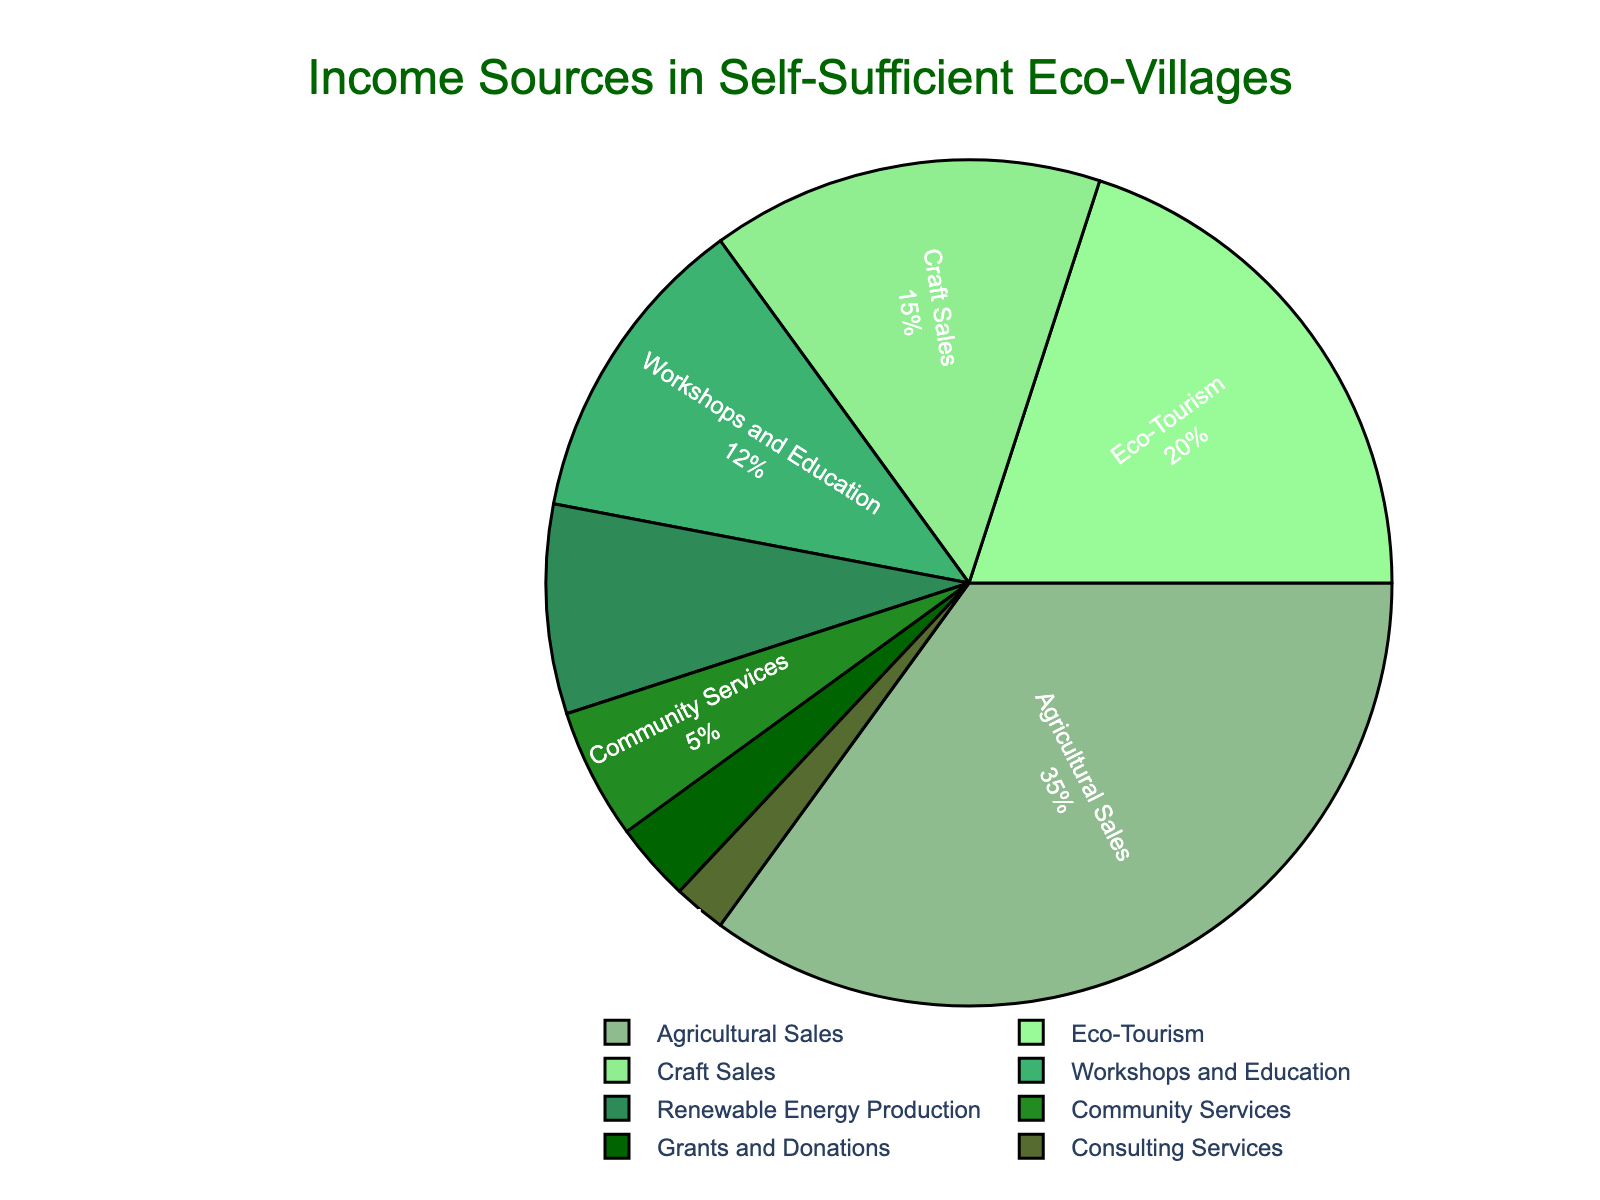What's the largest income source for the self-sufficient eco-villages? The largest portion of the pie chart represents Agricultural Sales, which is 35%.
Answer: Agricultural Sales How much more income does Agricultural Sales generate compared to Craft Sales? Agricultural Sales is 35%, and Craft Sales is 15%, so the difference is 35% - 15% = 20%.
Answer: 20% Which category contributes the least to the income? The smallest portion of the pie chart represents Consulting Services, which is 2%.
Answer: Consulting Services What percentage of the total income is generated by Eco-Tourism and Workshops and Education combined? The percentages for Eco-Tourism and Workshops and Education are 20% and 12% respectively. Summing them up, 20% + 12% = 32%.
Answer: 32% How does the income from Eco-Tourism compare to Renewable Energy Production? Eco-Tourism generates 20% of the income, while Renewable Energy Production generates 8%. Therefore, Eco-Tourism generates 20% - 8% = 12% more income.
Answer: 12% more What are the two income sources that contribute the most to the eco-village's income and what is their combined percentage? The two largest sources are Agricultural Sales (35%) and Eco-Tourism (20%). Combined, their contribution is 35% + 20% = 55%.
Answer: Agricultural Sales and Eco-Tourism, 55% What portion of the eco-village's income comes from education-related activities? Workshops and Education represent the portion related to education, which is 12%.
Answer: 12% How much more income does Community Services generate compared to Grants and Donations? Community Services contribute 5%, while Grants and Donations contribute 3%. Therefore, Community Services generate 5% - 3% = 2% more income.
Answer: 2% more What percentage of income comes from non-sales activities (excluding Agricultural Sales, Craft Sales, and Eco-Tourism)? Non-sales activities are Workshops and Education (12%), Renewable Energy Production (8%), Community Services (5%), Grants and Donations (3%), and Consulting Services (2%). Summing them up, 12% + 8% + 5% + 3% + 2% = 30%.
Answer: 30% What is the difference in the percentages between the top three income sources combined and the lowest three income sources combined? The top three sources are Agricultural Sales (35%), Eco-Tourism (20%), and Craft Sales (15%). Their combined percentage is 35% + 20% + 15% = 70%. The lowest three sources are Community Services (5%), Grants and Donations (3%), and Consulting Services (2%). Their combined percentage is 5% + 3% + 2% = 10%. The difference is 70% - 10% = 60%.
Answer: 60% 